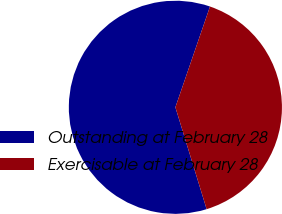Convert chart to OTSL. <chart><loc_0><loc_0><loc_500><loc_500><pie_chart><fcel>Outstanding at February 28<fcel>Exercisable at February 28<nl><fcel>60.0%<fcel>40.0%<nl></chart> 